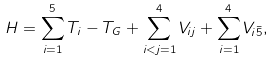Convert formula to latex. <formula><loc_0><loc_0><loc_500><loc_500>H = \sum _ { i = 1 } ^ { 5 } T _ { i } - T _ { G } + \sum _ { i < j = 1 } ^ { 4 } V _ { i j } + \sum _ { i = 1 } ^ { 4 } V _ { i \bar { 5 } } ,</formula> 